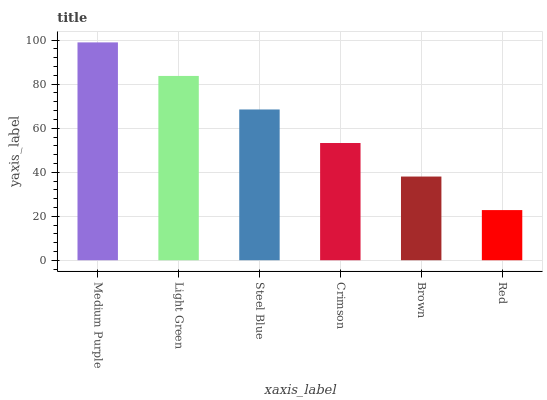Is Red the minimum?
Answer yes or no. Yes. Is Medium Purple the maximum?
Answer yes or no. Yes. Is Light Green the minimum?
Answer yes or no. No. Is Light Green the maximum?
Answer yes or no. No. Is Medium Purple greater than Light Green?
Answer yes or no. Yes. Is Light Green less than Medium Purple?
Answer yes or no. Yes. Is Light Green greater than Medium Purple?
Answer yes or no. No. Is Medium Purple less than Light Green?
Answer yes or no. No. Is Steel Blue the high median?
Answer yes or no. Yes. Is Crimson the low median?
Answer yes or no. Yes. Is Crimson the high median?
Answer yes or no. No. Is Red the low median?
Answer yes or no. No. 